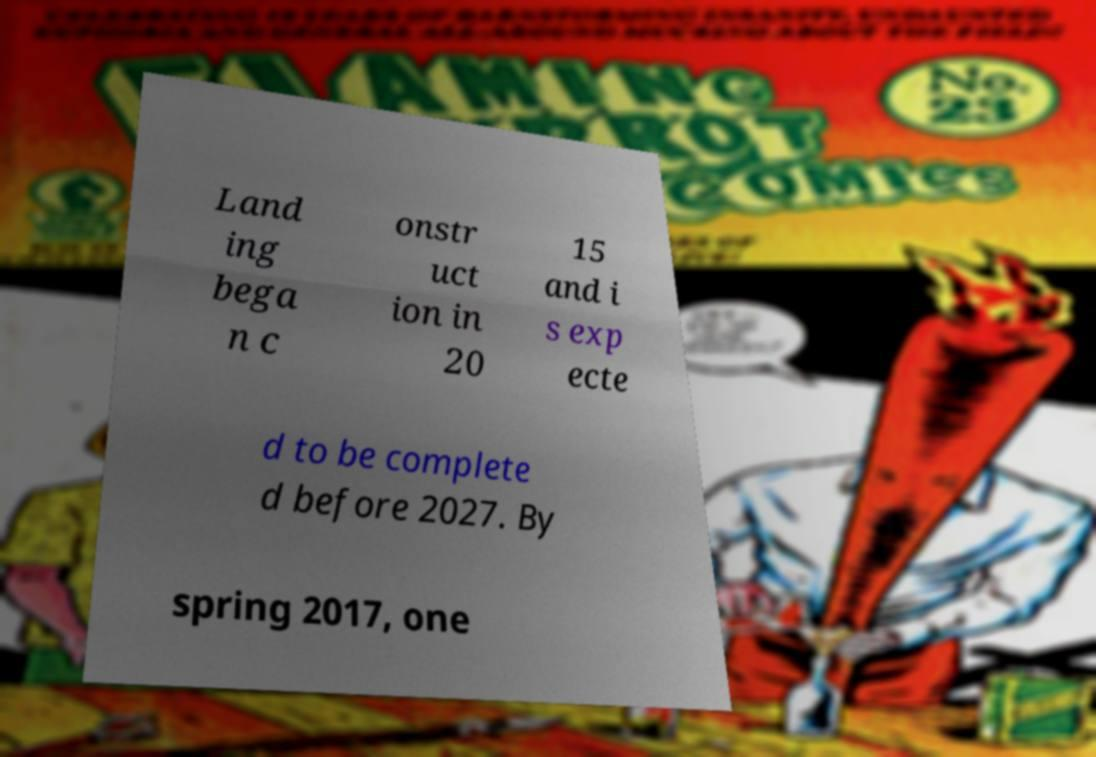Could you extract and type out the text from this image? Land ing bega n c onstr uct ion in 20 15 and i s exp ecte d to be complete d before 2027. By spring 2017, one 